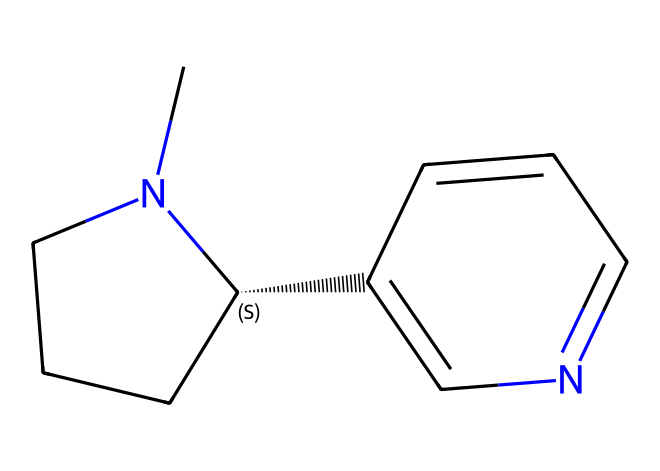What is the molecular formula of nicotine? To determine the molecular formula, we identify the number of each type of atom in the chemical structure. The SMILES notation indicates there are 10 carbon atoms, 14 hydrogen atoms, and 2 nitrogen atoms. Therefore, the molecular formula is C10H14N2.
Answer: C10H14N2 How many nitrogen atoms are present in nicotine? The SMILES representation contains two nitrogen atoms, which can be directly counted from the chemical structure outlined in the notation.
Answer: 2 What type of compound is nicotine categorized as? Nicotine is categorized as an alkaloid due to its nitrogen-containing structure and its occurrence in plants, particularly tobacco. Alkaloids are known for their pharmacological effects, particularly in plants.
Answer: alkaloid What configuration does the carbon chain in nicotine exhibit? In the structure, at least one carbon atom is indicative of a chiral center (the one labeled with '@' in the SMILES notation), which introduces stereochemistry to the molecule. This confirms that nicotine has chirality.
Answer: chiral What functional groups are present in nicotine? The nitrogen atoms in nicotine represent amine functional groups, and the presence of the double bond in the aromatic ring also suggests it has aromatic characteristics. Overall, the chemical has aromatic and amine functional groups.
Answer: aromatic and amine What is the significance of the nitrogen atoms in the structure of nicotine? The nitrogen atoms in nicotine are crucial as they contribute to the pharmacological properties of the compound, acting as electron donors which are vital for interaction with biological receptors, specifically in the nervous system.
Answer: pharmacological properties 